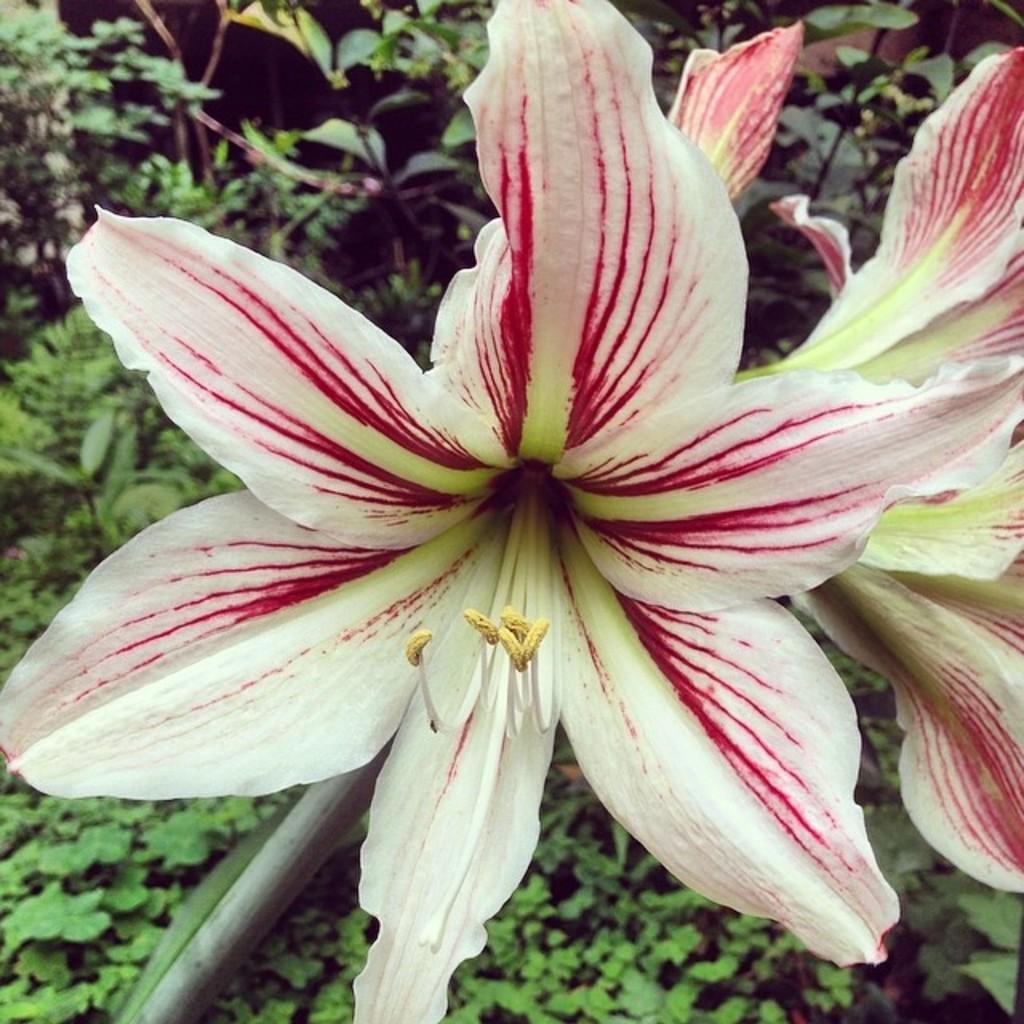In one or two sentences, can you explain what this image depicts? There are white and red color flowers. In the background there are plants. 